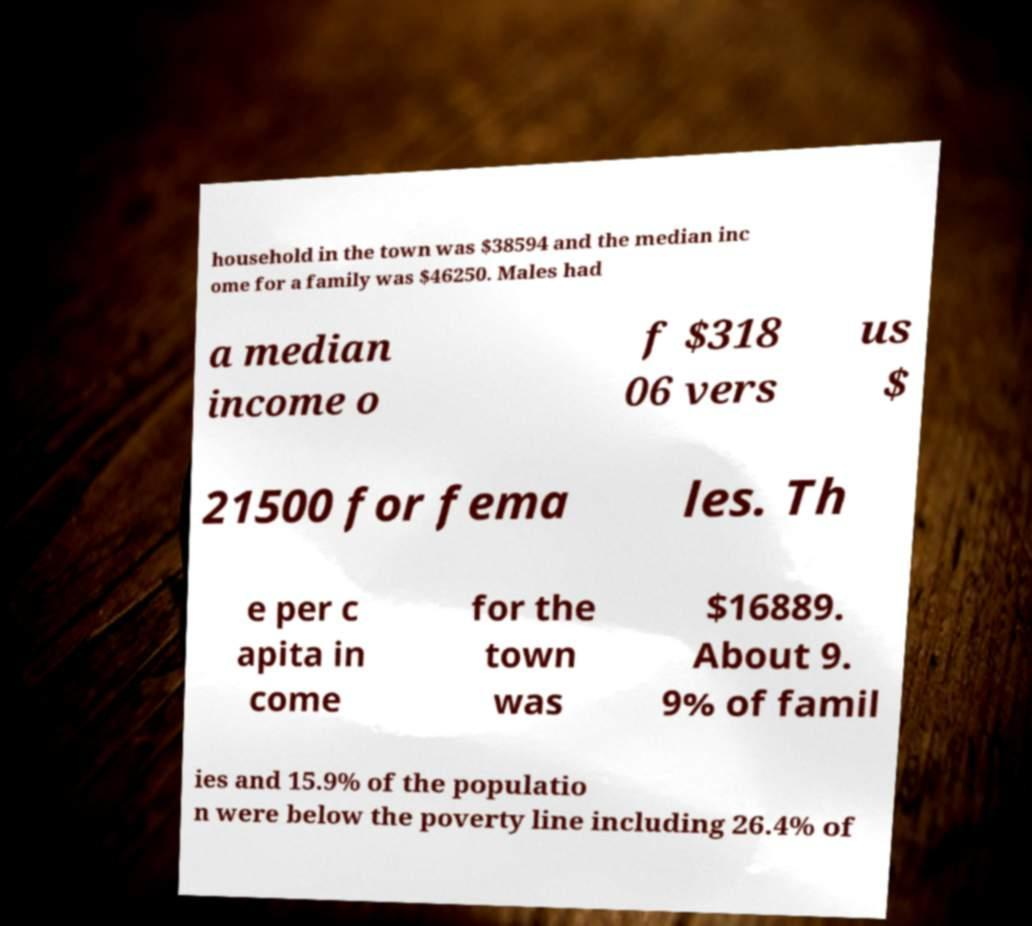There's text embedded in this image that I need extracted. Can you transcribe it verbatim? household in the town was $38594 and the median inc ome for a family was $46250. Males had a median income o f $318 06 vers us $ 21500 for fema les. Th e per c apita in come for the town was $16889. About 9. 9% of famil ies and 15.9% of the populatio n were below the poverty line including 26.4% of 